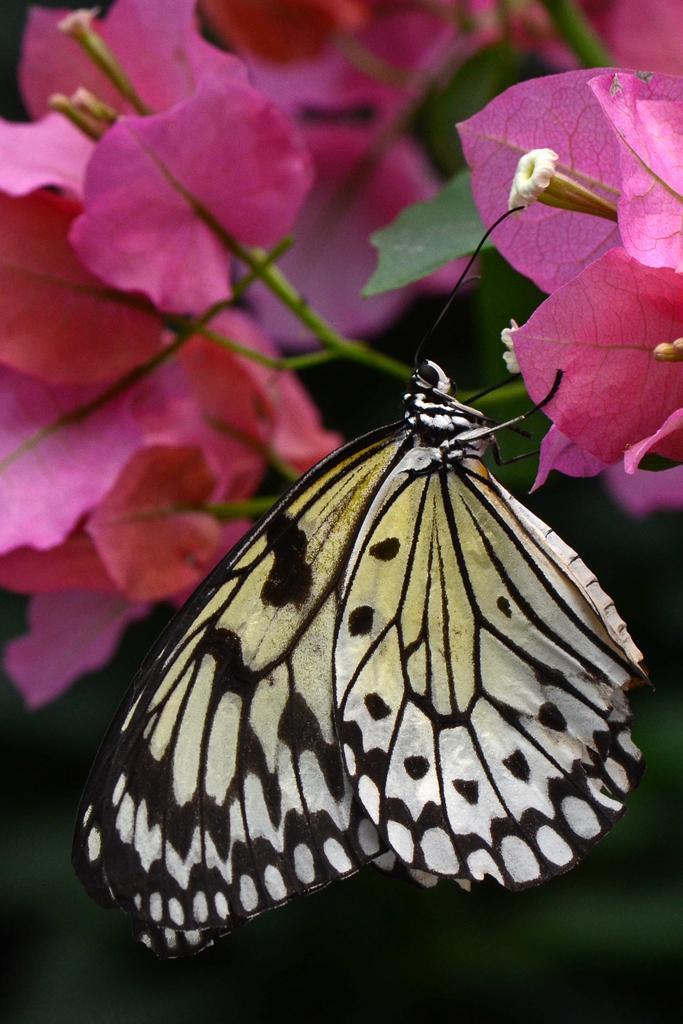Describe this image in one or two sentences. In this image we can see the butterfly on the pink color flower. In the background we can see the flowers. 